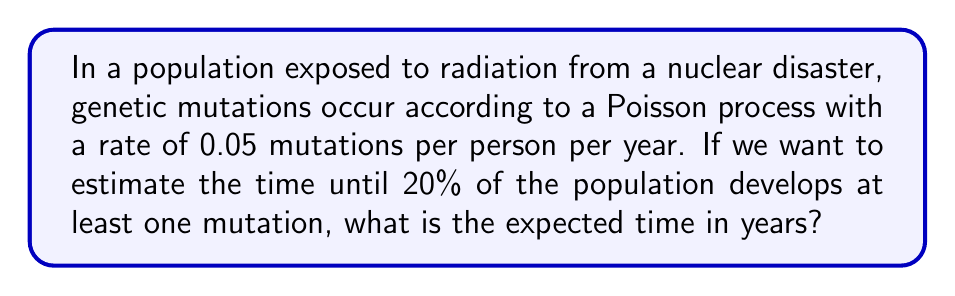Teach me how to tackle this problem. Let's approach this step-by-step:

1) In a Poisson process, the time until an event occurs follows an exponential distribution. The probability that an individual has not experienced a mutation by time $t$ is given by:

   $P(\text{no mutation by time } t) = e^{-\lambda t}$

   where $\lambda$ is the rate parameter (0.05 in this case).

2) Therefore, the probability that an individual has experienced at least one mutation by time $t$ is:

   $P(\text{at least one mutation by time } t) = 1 - e^{-\lambda t}$

3) We want to find $t$ when this probability equals 0.20 (20% of the population):

   $0.20 = 1 - e^{-0.05t}$

4) Solving for $t$:

   $e^{-0.05t} = 0.80$
   $-0.05t = \ln(0.80)$
   $t = -\frac{\ln(0.80)}{0.05}$

5) Calculating:

   $t = -\frac{\ln(0.80)}{0.05} \approx 4.46$ years

Therefore, we expect it to take approximately 4.46 years for 20% of the population to develop at least one mutation.
Answer: 4.46 years 